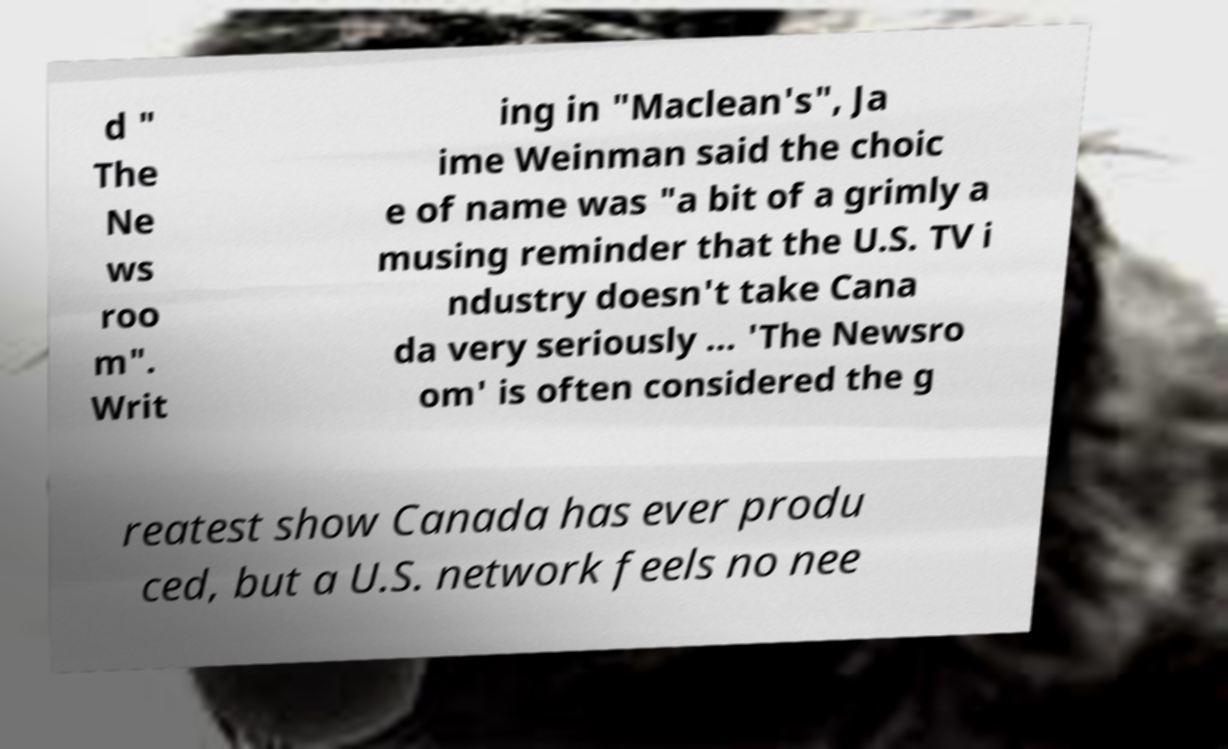For documentation purposes, I need the text within this image transcribed. Could you provide that? d " The Ne ws roo m". Writ ing in "Maclean's", Ja ime Weinman said the choic e of name was "a bit of a grimly a musing reminder that the U.S. TV i ndustry doesn't take Cana da very seriously ... 'The Newsro om' is often considered the g reatest show Canada has ever produ ced, but a U.S. network feels no nee 